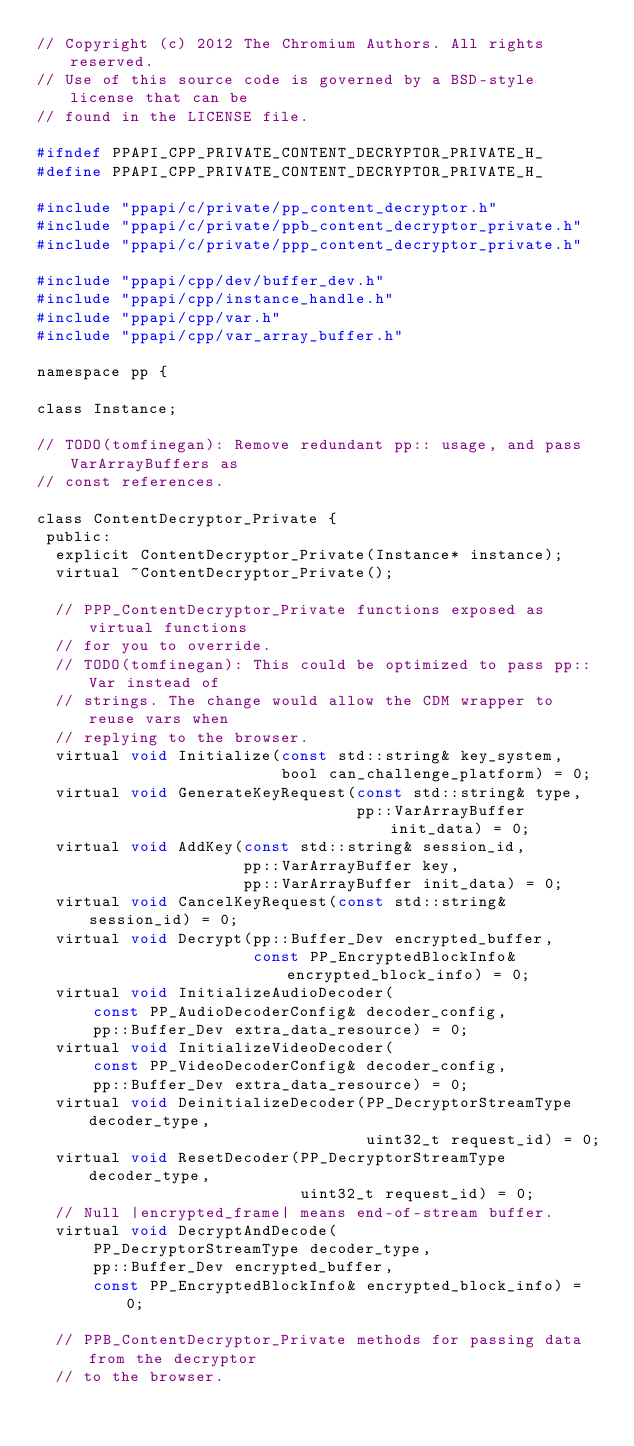<code> <loc_0><loc_0><loc_500><loc_500><_C_>// Copyright (c) 2012 The Chromium Authors. All rights reserved.
// Use of this source code is governed by a BSD-style license that can be
// found in the LICENSE file.

#ifndef PPAPI_CPP_PRIVATE_CONTENT_DECRYPTOR_PRIVATE_H_
#define PPAPI_CPP_PRIVATE_CONTENT_DECRYPTOR_PRIVATE_H_

#include "ppapi/c/private/pp_content_decryptor.h"
#include "ppapi/c/private/ppb_content_decryptor_private.h"
#include "ppapi/c/private/ppp_content_decryptor_private.h"

#include "ppapi/cpp/dev/buffer_dev.h"
#include "ppapi/cpp/instance_handle.h"
#include "ppapi/cpp/var.h"
#include "ppapi/cpp/var_array_buffer.h"

namespace pp {

class Instance;

// TODO(tomfinegan): Remove redundant pp:: usage, and pass VarArrayBuffers as
// const references.

class ContentDecryptor_Private {
 public:
  explicit ContentDecryptor_Private(Instance* instance);
  virtual ~ContentDecryptor_Private();

  // PPP_ContentDecryptor_Private functions exposed as virtual functions
  // for you to override.
  // TODO(tomfinegan): This could be optimized to pass pp::Var instead of
  // strings. The change would allow the CDM wrapper to reuse vars when
  // replying to the browser.
  virtual void Initialize(const std::string& key_system,
                          bool can_challenge_platform) = 0;
  virtual void GenerateKeyRequest(const std::string& type,
                                  pp::VarArrayBuffer init_data) = 0;
  virtual void AddKey(const std::string& session_id,
                      pp::VarArrayBuffer key,
                      pp::VarArrayBuffer init_data) = 0;
  virtual void CancelKeyRequest(const std::string& session_id) = 0;
  virtual void Decrypt(pp::Buffer_Dev encrypted_buffer,
                       const PP_EncryptedBlockInfo& encrypted_block_info) = 0;
  virtual void InitializeAudioDecoder(
      const PP_AudioDecoderConfig& decoder_config,
      pp::Buffer_Dev extra_data_resource) = 0;
  virtual void InitializeVideoDecoder(
      const PP_VideoDecoderConfig& decoder_config,
      pp::Buffer_Dev extra_data_resource) = 0;
  virtual void DeinitializeDecoder(PP_DecryptorStreamType decoder_type,
                                   uint32_t request_id) = 0;
  virtual void ResetDecoder(PP_DecryptorStreamType decoder_type,
                            uint32_t request_id) = 0;
  // Null |encrypted_frame| means end-of-stream buffer.
  virtual void DecryptAndDecode(
      PP_DecryptorStreamType decoder_type,
      pp::Buffer_Dev encrypted_buffer,
      const PP_EncryptedBlockInfo& encrypted_block_info) = 0;

  // PPB_ContentDecryptor_Private methods for passing data from the decryptor
  // to the browser.</code> 